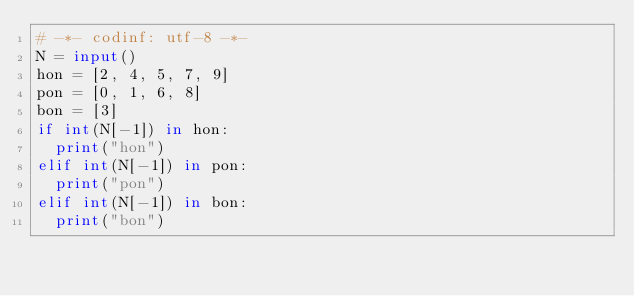<code> <loc_0><loc_0><loc_500><loc_500><_Python_># -*- codinf: utf-8 -*-
N = input()
hon = [2, 4, 5, 7, 9]
pon = [0, 1, 6, 8]
bon = [3]
if int(N[-1]) in hon:
  print("hon")
elif int(N[-1]) in pon:
  print("pon")
elif int(N[-1]) in bon:
  print("bon")</code> 